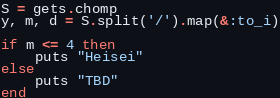<code> <loc_0><loc_0><loc_500><loc_500><_Ruby_>S = gets.chomp
y, m, d = S.split('/').map(&:to_i)

if m <= 4 then
    puts "Heisei"
else
    puts "TBD"
end</code> 